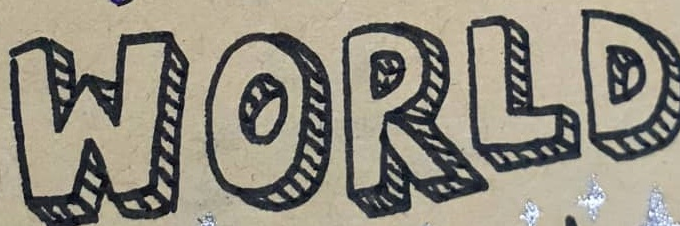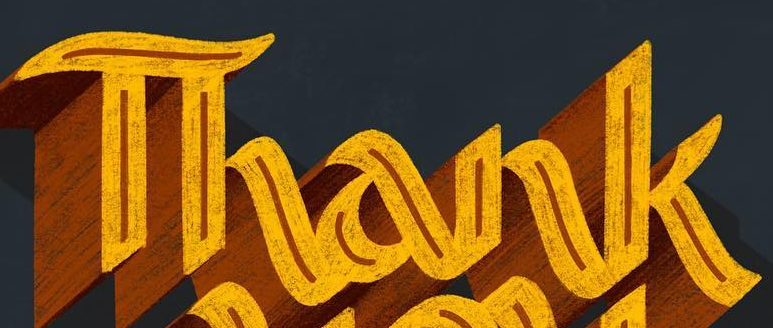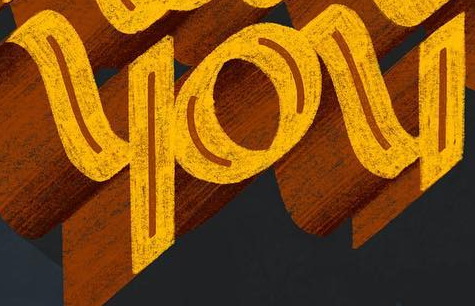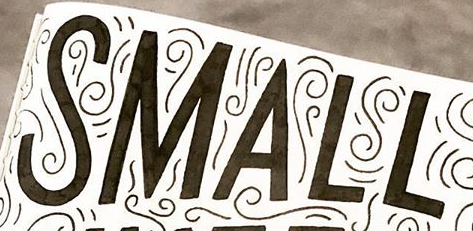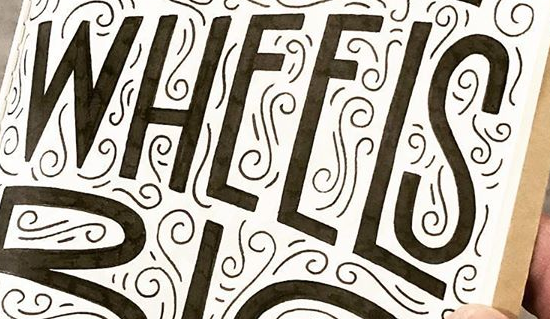Read the text from these images in sequence, separated by a semicolon. WORLD; Thank; you; SMALL; WHEELS 